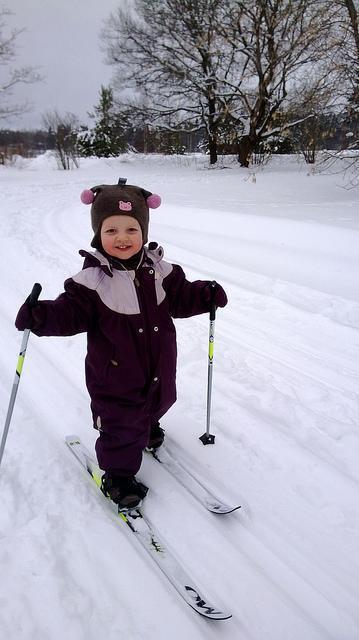How many umbrellas can you see?
Give a very brief answer. 0. 